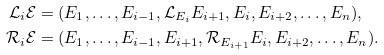<formula> <loc_0><loc_0><loc_500><loc_500>\mathcal { L } _ { i } \mathcal { E } & = ( E _ { 1 } , \dots , E _ { i - 1 } , \mathcal { L } _ { E _ { i } } E _ { i + 1 } , E _ { i } , E _ { i + 2 } , \dots , E _ { n } ) , \\ \mathcal { R } _ { i } \mathcal { E } & = ( E _ { 1 } , \dots , E _ { i - 1 } , E _ { i + 1 } , \mathcal { R } _ { E _ { i + 1 } } E _ { i } , E _ { i + 2 } , \dots , E _ { n } ) .</formula> 